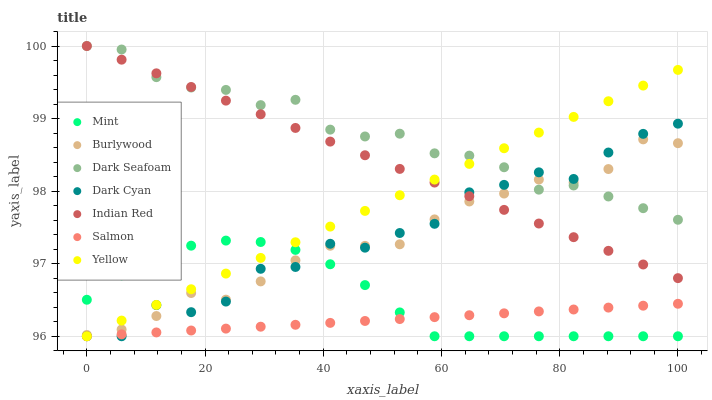Does Salmon have the minimum area under the curve?
Answer yes or no. Yes. Does Dark Seafoam have the maximum area under the curve?
Answer yes or no. Yes. Does Yellow have the minimum area under the curve?
Answer yes or no. No. Does Yellow have the maximum area under the curve?
Answer yes or no. No. Is Salmon the smoothest?
Answer yes or no. Yes. Is Dark Cyan the roughest?
Answer yes or no. Yes. Is Yellow the smoothest?
Answer yes or no. No. Is Yellow the roughest?
Answer yes or no. No. Does Salmon have the lowest value?
Answer yes or no. Yes. Does Dark Seafoam have the lowest value?
Answer yes or no. No. Does Indian Red have the highest value?
Answer yes or no. Yes. Does Yellow have the highest value?
Answer yes or no. No. Is Salmon less than Burlywood?
Answer yes or no. Yes. Is Burlywood greater than Salmon?
Answer yes or no. Yes. Does Mint intersect Salmon?
Answer yes or no. Yes. Is Mint less than Salmon?
Answer yes or no. No. Is Mint greater than Salmon?
Answer yes or no. No. Does Salmon intersect Burlywood?
Answer yes or no. No. 